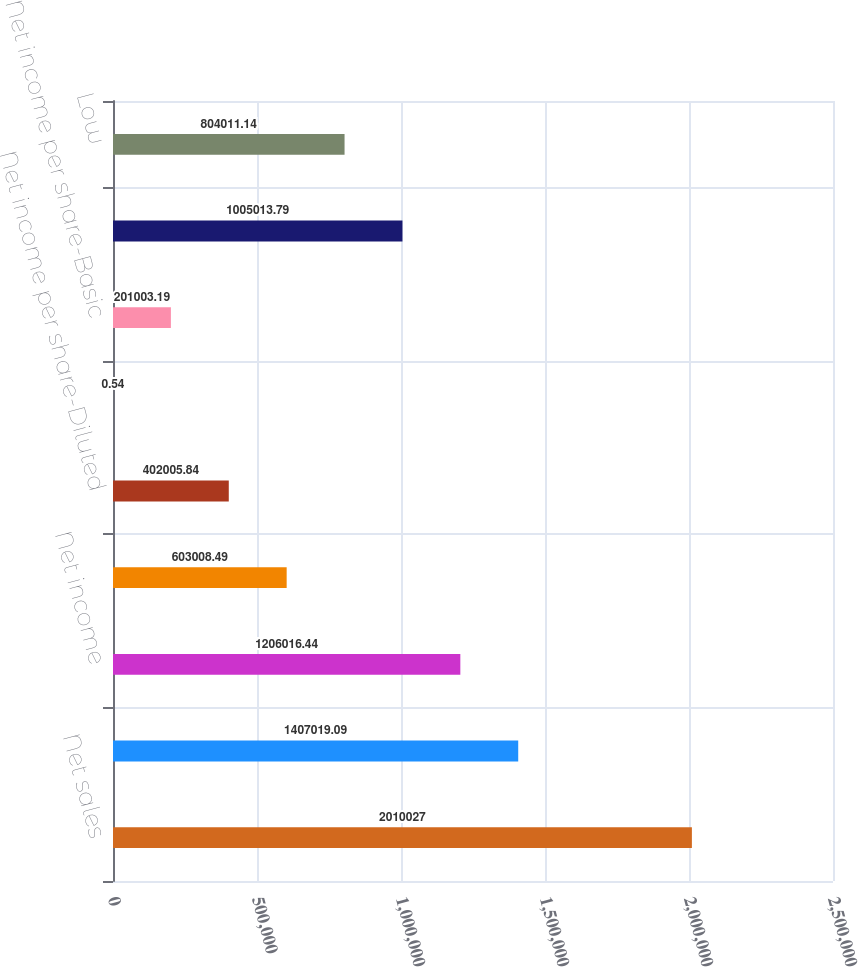<chart> <loc_0><loc_0><loc_500><loc_500><bar_chart><fcel>Net sales<fcel>Gross profit<fcel>Net income<fcel>Net income per share-Basic (a)<fcel>Net income per share-Diluted<fcel>Dividends paid per share<fcel>Net income per share-Basic<fcel>High<fcel>Low<nl><fcel>2.01003e+06<fcel>1.40702e+06<fcel>1.20602e+06<fcel>603008<fcel>402006<fcel>0.54<fcel>201003<fcel>1.00501e+06<fcel>804011<nl></chart> 